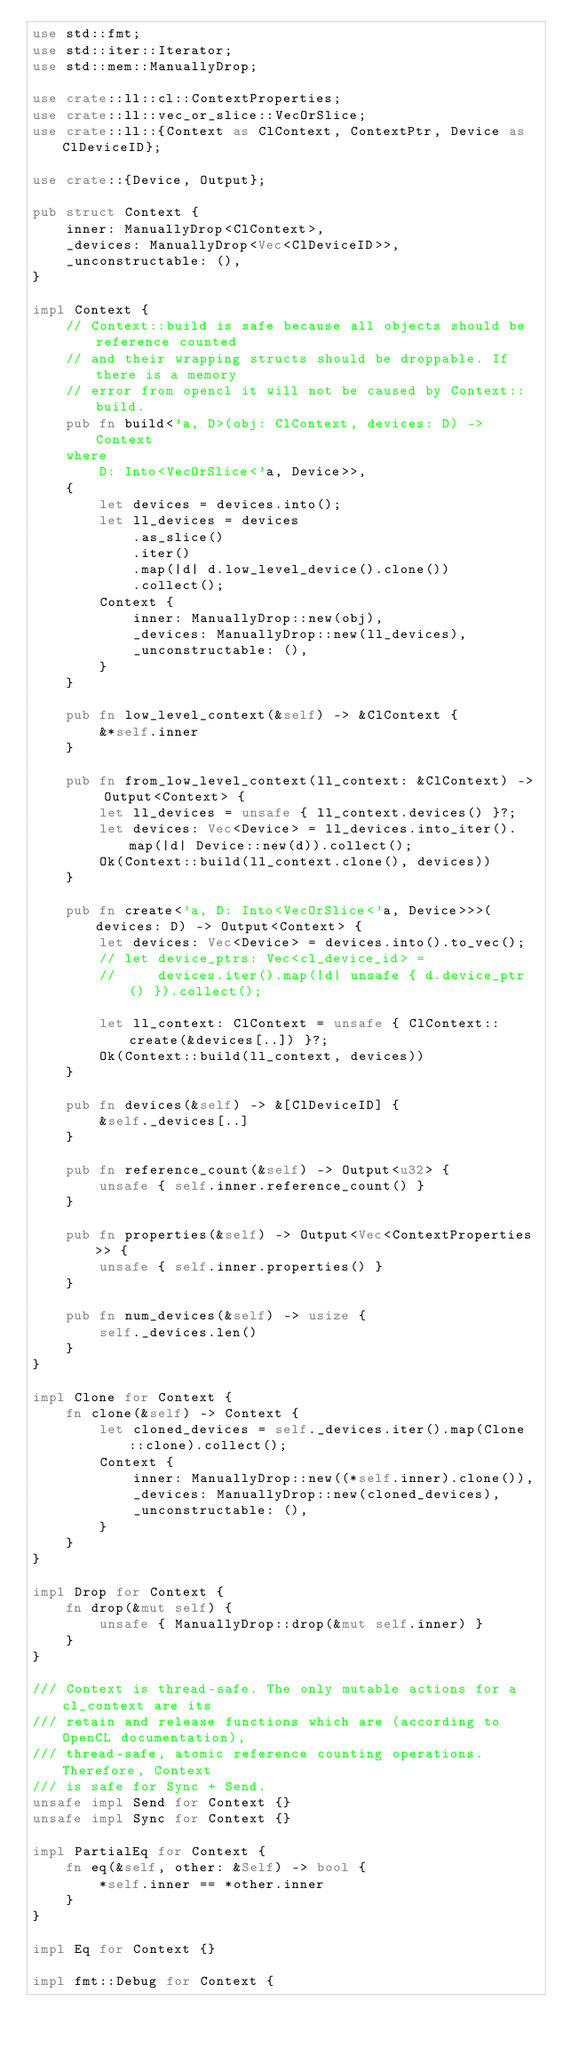Convert code to text. <code><loc_0><loc_0><loc_500><loc_500><_Rust_>use std::fmt;
use std::iter::Iterator;
use std::mem::ManuallyDrop;

use crate::ll::cl::ContextProperties;
use crate::ll::vec_or_slice::VecOrSlice;
use crate::ll::{Context as ClContext, ContextPtr, Device as ClDeviceID};

use crate::{Device, Output};

pub struct Context {
    inner: ManuallyDrop<ClContext>,
    _devices: ManuallyDrop<Vec<ClDeviceID>>,
    _unconstructable: (),
}

impl Context {
    // Context::build is safe because all objects should be reference counted
    // and their wrapping structs should be droppable. If there is a memory
    // error from opencl it will not be caused by Context::build.
    pub fn build<'a, D>(obj: ClContext, devices: D) -> Context
    where
        D: Into<VecOrSlice<'a, Device>>,
    {
        let devices = devices.into();
        let ll_devices = devices
            .as_slice()
            .iter()
            .map(|d| d.low_level_device().clone())
            .collect();
        Context {
            inner: ManuallyDrop::new(obj),
            _devices: ManuallyDrop::new(ll_devices),
            _unconstructable: (),
        }
    }

    pub fn low_level_context(&self) -> &ClContext {
        &*self.inner
    }

    pub fn from_low_level_context(ll_context: &ClContext) -> Output<Context> {
        let ll_devices = unsafe { ll_context.devices() }?;
        let devices: Vec<Device> = ll_devices.into_iter().map(|d| Device::new(d)).collect();
        Ok(Context::build(ll_context.clone(), devices))
    }

    pub fn create<'a, D: Into<VecOrSlice<'a, Device>>>(devices: D) -> Output<Context> {
        let devices: Vec<Device> = devices.into().to_vec();
        // let device_ptrs: Vec<cl_device_id> =
        //     devices.iter().map(|d| unsafe { d.device_ptr() }).collect();

        let ll_context: ClContext = unsafe { ClContext::create(&devices[..]) }?;
        Ok(Context::build(ll_context, devices))
    }

    pub fn devices(&self) -> &[ClDeviceID] {
        &self._devices[..]
    }

    pub fn reference_count(&self) -> Output<u32> {
        unsafe { self.inner.reference_count() }
    }

    pub fn properties(&self) -> Output<Vec<ContextProperties>> {
        unsafe { self.inner.properties() }
    }

    pub fn num_devices(&self) -> usize {
        self._devices.len()
    }
}

impl Clone for Context {
    fn clone(&self) -> Context {
        let cloned_devices = self._devices.iter().map(Clone::clone).collect();
        Context {
            inner: ManuallyDrop::new((*self.inner).clone()),
            _devices: ManuallyDrop::new(cloned_devices),
            _unconstructable: (),
        }
    }
}

impl Drop for Context {
    fn drop(&mut self) {
        unsafe { ManuallyDrop::drop(&mut self.inner) }
    }
}

/// Context is thread-safe. The only mutable actions for a cl_context are its
/// retain and release functions which are (according to OpenCL documentation),
/// thread-safe, atomic reference counting operations. Therefore, Context
/// is safe for Sync + Send.
unsafe impl Send for Context {}
unsafe impl Sync for Context {}

impl PartialEq for Context {
    fn eq(&self, other: &Self) -> bool {
        *self.inner == *other.inner
    }
}

impl Eq for Context {}

impl fmt::Debug for Context {</code> 